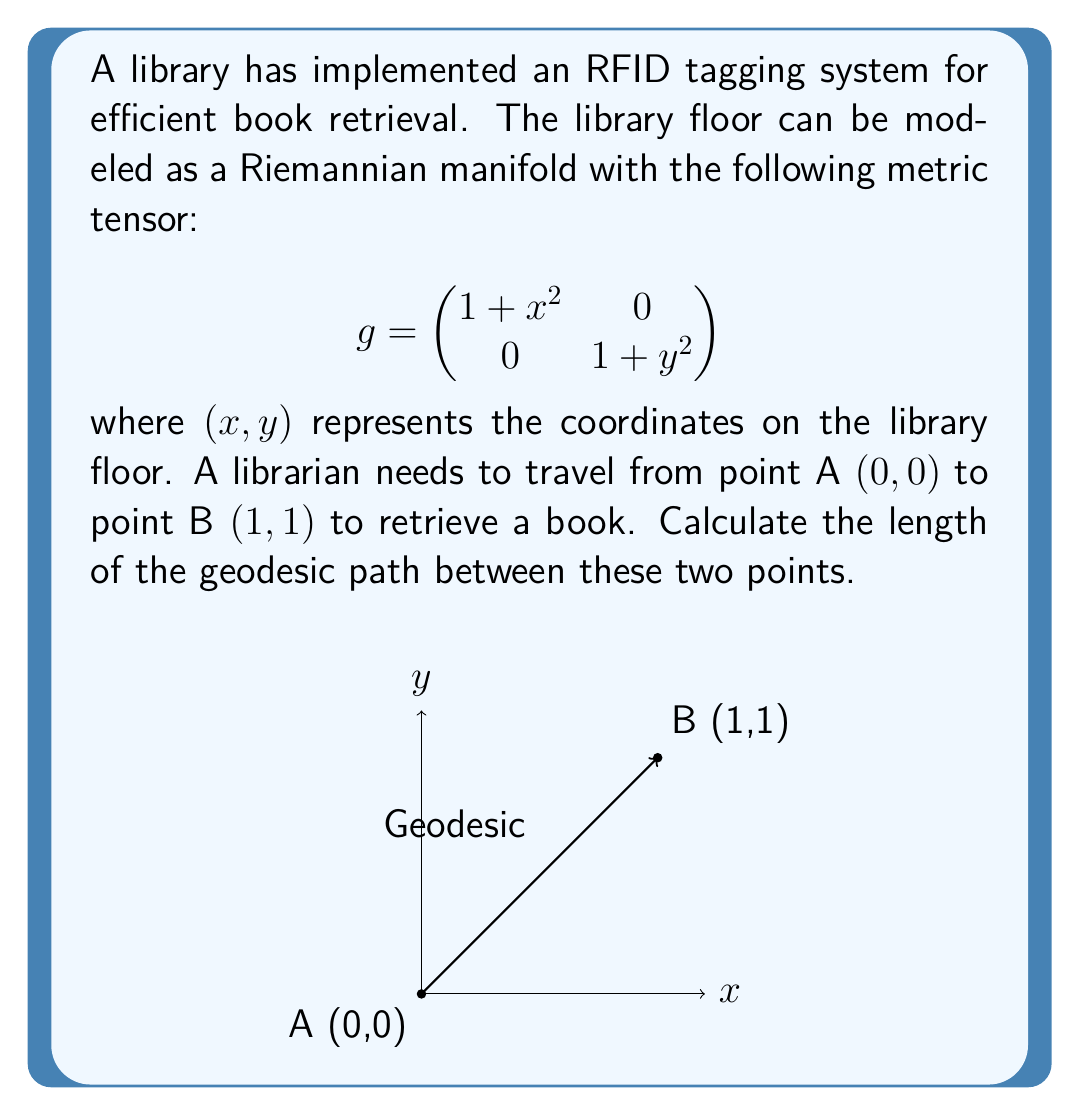Give your solution to this math problem. To solve this problem, we'll follow these steps:

1) The geodesic equation for a curve $\gamma(t) = (x(t), y(t))$ on a Riemannian manifold is given by:

   $$\frac{d^2x^i}{dt^2} + \Gamma^i_{jk}\frac{dx^j}{dt}\frac{dx^k}{dt} = 0$$

   where $\Gamma^i_{jk}$ are the Christoffel symbols.

2) For our metric, the non-zero Christoffel symbols are:

   $$\Gamma^1_{11} = \frac{x}{1+x^2}, \quad \Gamma^2_{22} = \frac{y}{1+y^2}$$

3) The geodesic equations become:

   $$\frac{d^2x}{dt^2} + \frac{x}{1+x^2}\left(\frac{dx}{dt}\right)^2 = 0$$
   $$\frac{d^2y}{dt^2} + \frac{y}{1+y^2}\left(\frac{dy}{dt}\right)^2 = 0$$

4) These equations are difficult to solve analytically. However, we can use a numerical method or a geodesic approximation.

5) For a first-order approximation, we can assume the geodesic is close to a straight line. The parametric equations for this line are:

   $$x(t) = t, \quad y(t) = t, \quad 0 \leq t \leq 1$$

6) The length of a curve $\gamma(t) = (x(t), y(t))$ on our Riemannian manifold is given by:

   $$L = \int_0^1 \sqrt{(1+x^2)\left(\frac{dx}{dt}\right)^2 + (1+y^2)\left(\frac{dy}{dt}\right)^2} dt$$

7) Substituting our approximation:

   $$L = \int_0^1 \sqrt{(1+t^2) + (1+t^2)} dt = \int_0^1 \sqrt{2(1+t^2)} dt$$

8) This integral can be solved:

   $$L = \sqrt{2} \int_0^1 \sqrt{1+t^2} dt = \sqrt{2} \left[\frac{t}{2}\sqrt{1+t^2} + \frac{1}{2}\ln(t+\sqrt{1+t^2})\right]_0^1$$

9) Evaluating the integral:

   $$L = \sqrt{2} \left[\frac{1}{2}\sqrt{2} + \frac{1}{2}\ln(1+\sqrt{2}) - 0\right] = \frac{\sqrt{4} + \sqrt{2}\ln(1+\sqrt{2})}{2}$$
Answer: $\frac{\sqrt{4} + \sqrt{2}\ln(1+\sqrt{2})}{2}$ 